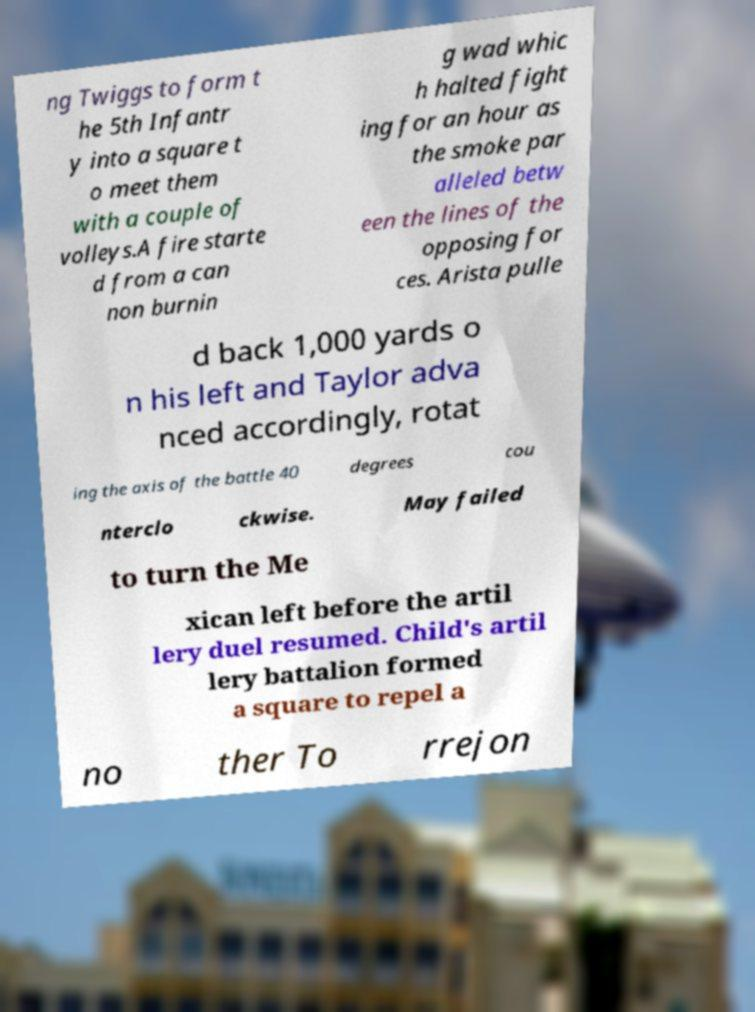Could you assist in decoding the text presented in this image and type it out clearly? ng Twiggs to form t he 5th Infantr y into a square t o meet them with a couple of volleys.A fire starte d from a can non burnin g wad whic h halted fight ing for an hour as the smoke par alleled betw een the lines of the opposing for ces. Arista pulle d back 1,000 yards o n his left and Taylor adva nced accordingly, rotat ing the axis of the battle 40 degrees cou nterclo ckwise. May failed to turn the Me xican left before the artil lery duel resumed. Child's artil lery battalion formed a square to repel a no ther To rrejon 